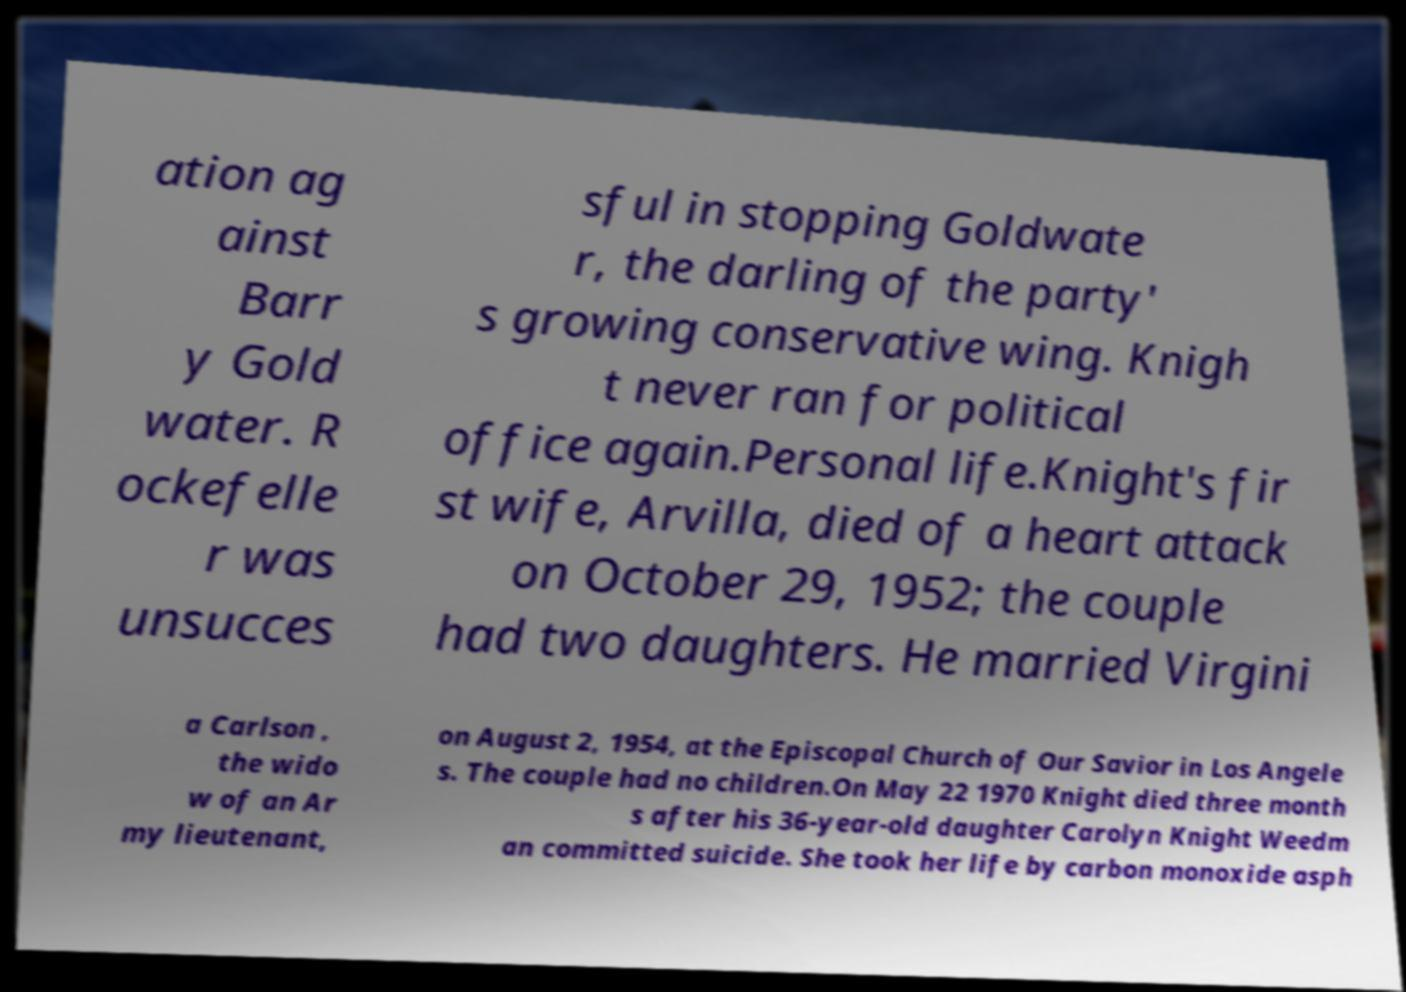Can you read and provide the text displayed in the image?This photo seems to have some interesting text. Can you extract and type it out for me? ation ag ainst Barr y Gold water. R ockefelle r was unsucces sful in stopping Goldwate r, the darling of the party' s growing conservative wing. Knigh t never ran for political office again.Personal life.Knight's fir st wife, Arvilla, died of a heart attack on October 29, 1952; the couple had two daughters. He married Virgini a Carlson , the wido w of an Ar my lieutenant, on August 2, 1954, at the Episcopal Church of Our Savior in Los Angele s. The couple had no children.On May 22 1970 Knight died three month s after his 36-year-old daughter Carolyn Knight Weedm an committed suicide. She took her life by carbon monoxide asph 